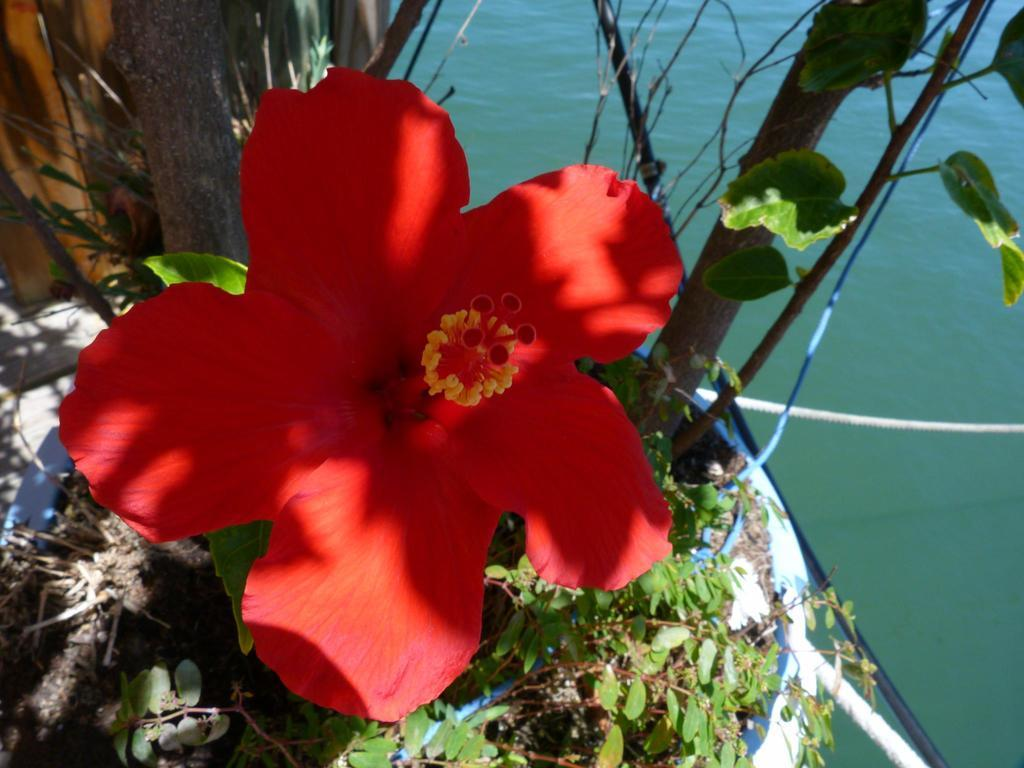What type of plant is present in the image? There is a flower in the image. What other types of plants can be seen in the image? There are plants in the image. What are the ropes used for in the image? The purpose of the ropes in the image is not specified, but they are visible. What is the primary liquid visible in the image? Water is visible in the image. How many units of hand sanitizer are visible in the image? There is no hand sanitizer present in the image. What type of edge can be seen on the flower in the image? The flower in the image does not have an edge, as it is a three-dimensional object. 